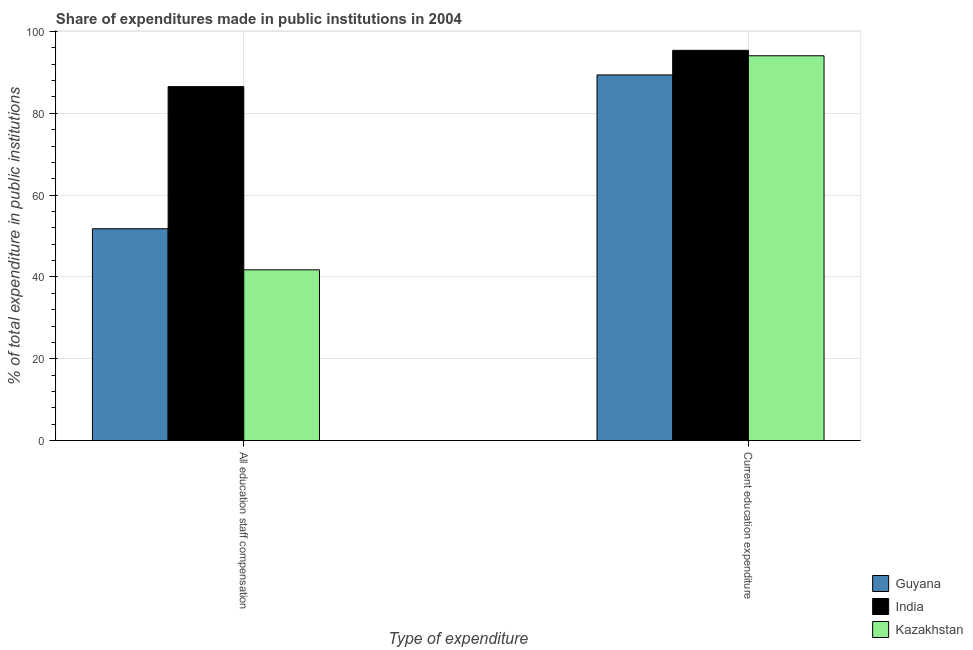How many different coloured bars are there?
Keep it short and to the point. 3. Are the number of bars on each tick of the X-axis equal?
Give a very brief answer. Yes. How many bars are there on the 1st tick from the right?
Your response must be concise. 3. What is the label of the 2nd group of bars from the left?
Provide a short and direct response. Current education expenditure. What is the expenditure in staff compensation in Guyana?
Offer a very short reply. 51.79. Across all countries, what is the maximum expenditure in staff compensation?
Your answer should be compact. 86.52. Across all countries, what is the minimum expenditure in education?
Provide a short and direct response. 89.39. In which country was the expenditure in education minimum?
Ensure brevity in your answer.  Guyana. What is the total expenditure in education in the graph?
Your answer should be compact. 278.86. What is the difference between the expenditure in education in Guyana and that in India?
Your answer should be very brief. -6.01. What is the difference between the expenditure in staff compensation in Kazakhstan and the expenditure in education in Guyana?
Make the answer very short. -47.65. What is the average expenditure in education per country?
Your response must be concise. 92.95. What is the difference between the expenditure in education and expenditure in staff compensation in Kazakhstan?
Provide a short and direct response. 52.33. What is the ratio of the expenditure in staff compensation in India to that in Guyana?
Give a very brief answer. 1.67. Is the expenditure in staff compensation in Kazakhstan less than that in Guyana?
Ensure brevity in your answer.  Yes. What does the 3rd bar from the left in All education staff compensation represents?
Provide a succinct answer. Kazakhstan. What does the 1st bar from the right in Current education expenditure represents?
Make the answer very short. Kazakhstan. How many bars are there?
Your answer should be very brief. 6. What is the difference between two consecutive major ticks on the Y-axis?
Offer a very short reply. 20. What is the title of the graph?
Provide a short and direct response. Share of expenditures made in public institutions in 2004. What is the label or title of the X-axis?
Your response must be concise. Type of expenditure. What is the label or title of the Y-axis?
Your answer should be compact. % of total expenditure in public institutions. What is the % of total expenditure in public institutions in Guyana in All education staff compensation?
Keep it short and to the point. 51.79. What is the % of total expenditure in public institutions of India in All education staff compensation?
Your answer should be very brief. 86.52. What is the % of total expenditure in public institutions in Kazakhstan in All education staff compensation?
Ensure brevity in your answer.  41.74. What is the % of total expenditure in public institutions of Guyana in Current education expenditure?
Make the answer very short. 89.39. What is the % of total expenditure in public institutions in India in Current education expenditure?
Make the answer very short. 95.4. What is the % of total expenditure in public institutions of Kazakhstan in Current education expenditure?
Make the answer very short. 94.07. Across all Type of expenditure, what is the maximum % of total expenditure in public institutions in Guyana?
Your answer should be very brief. 89.39. Across all Type of expenditure, what is the maximum % of total expenditure in public institutions in India?
Your answer should be compact. 95.4. Across all Type of expenditure, what is the maximum % of total expenditure in public institutions in Kazakhstan?
Keep it short and to the point. 94.07. Across all Type of expenditure, what is the minimum % of total expenditure in public institutions in Guyana?
Your answer should be compact. 51.79. Across all Type of expenditure, what is the minimum % of total expenditure in public institutions in India?
Provide a short and direct response. 86.52. Across all Type of expenditure, what is the minimum % of total expenditure in public institutions of Kazakhstan?
Your answer should be very brief. 41.74. What is the total % of total expenditure in public institutions in Guyana in the graph?
Give a very brief answer. 141.17. What is the total % of total expenditure in public institutions in India in the graph?
Your answer should be compact. 181.92. What is the total % of total expenditure in public institutions in Kazakhstan in the graph?
Keep it short and to the point. 135.81. What is the difference between the % of total expenditure in public institutions in Guyana in All education staff compensation and that in Current education expenditure?
Your response must be concise. -37.6. What is the difference between the % of total expenditure in public institutions of India in All education staff compensation and that in Current education expenditure?
Provide a succinct answer. -8.88. What is the difference between the % of total expenditure in public institutions in Kazakhstan in All education staff compensation and that in Current education expenditure?
Make the answer very short. -52.33. What is the difference between the % of total expenditure in public institutions in Guyana in All education staff compensation and the % of total expenditure in public institutions in India in Current education expenditure?
Offer a terse response. -43.61. What is the difference between the % of total expenditure in public institutions in Guyana in All education staff compensation and the % of total expenditure in public institutions in Kazakhstan in Current education expenditure?
Your response must be concise. -42.29. What is the difference between the % of total expenditure in public institutions of India in All education staff compensation and the % of total expenditure in public institutions of Kazakhstan in Current education expenditure?
Offer a very short reply. -7.55. What is the average % of total expenditure in public institutions of Guyana per Type of expenditure?
Provide a short and direct response. 70.59. What is the average % of total expenditure in public institutions in India per Type of expenditure?
Keep it short and to the point. 90.96. What is the average % of total expenditure in public institutions of Kazakhstan per Type of expenditure?
Your answer should be compact. 67.91. What is the difference between the % of total expenditure in public institutions of Guyana and % of total expenditure in public institutions of India in All education staff compensation?
Offer a terse response. -34.74. What is the difference between the % of total expenditure in public institutions in Guyana and % of total expenditure in public institutions in Kazakhstan in All education staff compensation?
Provide a succinct answer. 10.05. What is the difference between the % of total expenditure in public institutions of India and % of total expenditure in public institutions of Kazakhstan in All education staff compensation?
Keep it short and to the point. 44.78. What is the difference between the % of total expenditure in public institutions of Guyana and % of total expenditure in public institutions of India in Current education expenditure?
Provide a succinct answer. -6.01. What is the difference between the % of total expenditure in public institutions in Guyana and % of total expenditure in public institutions in Kazakhstan in Current education expenditure?
Give a very brief answer. -4.69. What is the difference between the % of total expenditure in public institutions in India and % of total expenditure in public institutions in Kazakhstan in Current education expenditure?
Make the answer very short. 1.33. What is the ratio of the % of total expenditure in public institutions of Guyana in All education staff compensation to that in Current education expenditure?
Your answer should be compact. 0.58. What is the ratio of the % of total expenditure in public institutions in India in All education staff compensation to that in Current education expenditure?
Provide a succinct answer. 0.91. What is the ratio of the % of total expenditure in public institutions in Kazakhstan in All education staff compensation to that in Current education expenditure?
Your answer should be compact. 0.44. What is the difference between the highest and the second highest % of total expenditure in public institutions in Guyana?
Offer a terse response. 37.6. What is the difference between the highest and the second highest % of total expenditure in public institutions of India?
Make the answer very short. 8.88. What is the difference between the highest and the second highest % of total expenditure in public institutions in Kazakhstan?
Your answer should be very brief. 52.33. What is the difference between the highest and the lowest % of total expenditure in public institutions of Guyana?
Offer a very short reply. 37.6. What is the difference between the highest and the lowest % of total expenditure in public institutions in India?
Provide a succinct answer. 8.88. What is the difference between the highest and the lowest % of total expenditure in public institutions in Kazakhstan?
Provide a short and direct response. 52.33. 